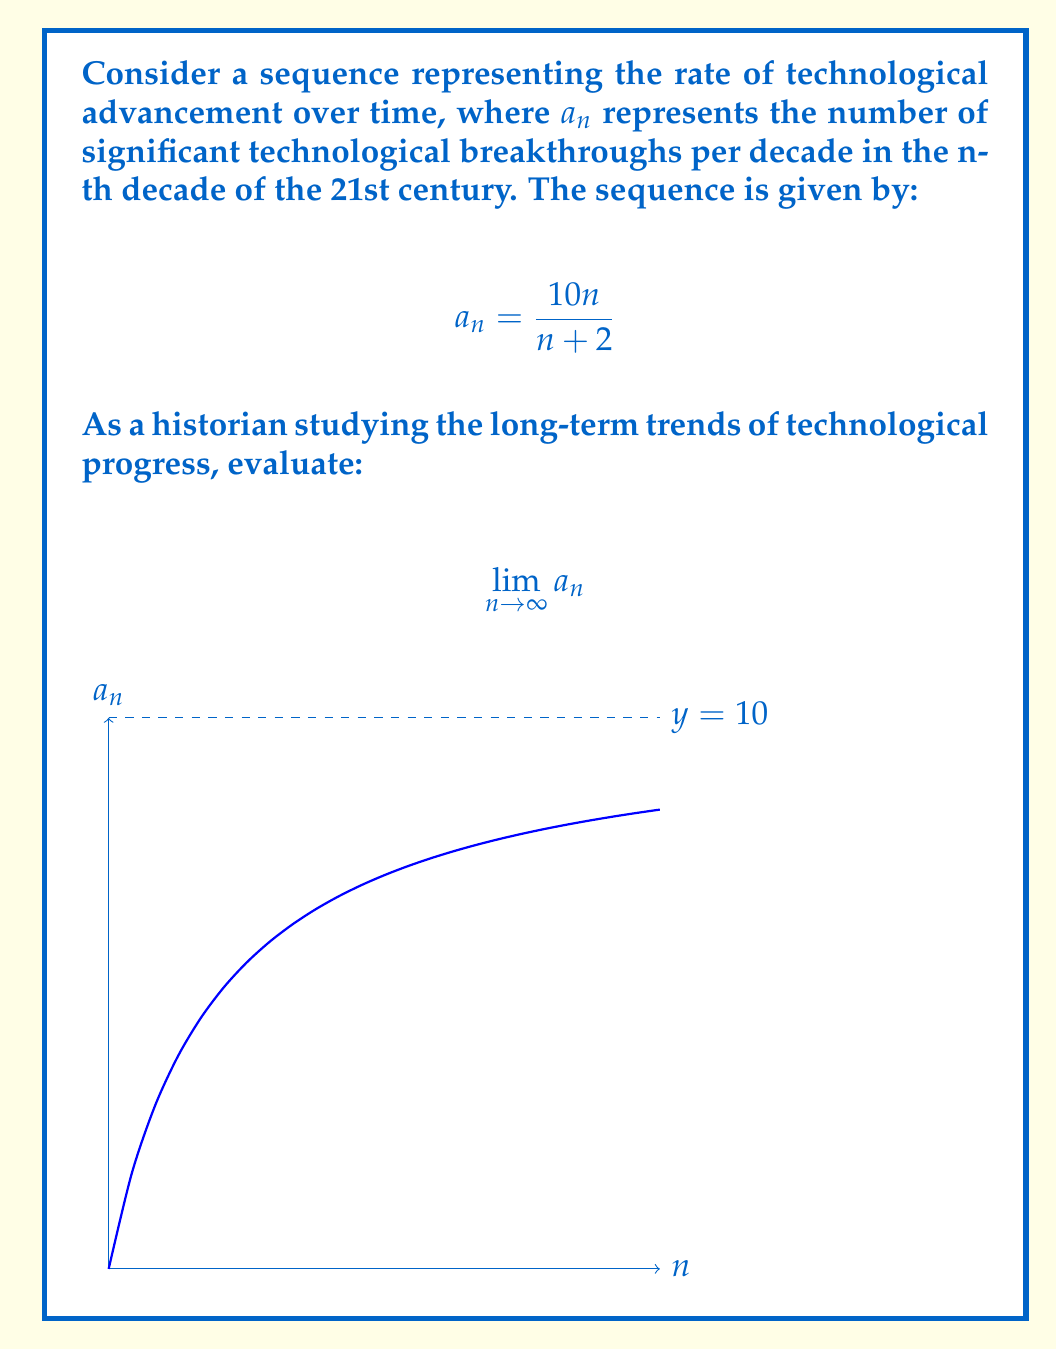Can you solve this math problem? To evaluate this limit, we'll follow these steps:

1) First, let's consider the behavior of the function as n approaches infinity:

   $$\lim_{n \to \infty} \frac{10n}{n+2}$$

2) Both the numerator and denominator approach infinity as n grows large. This is an indeterminate form of type $\frac{\infty}{\infty}$.

3) To resolve this, we can divide both the numerator and denominator by the highest power of n, which is n:

   $$\lim_{n \to \infty} \frac{10n}{n+2} = \lim_{n \to \infty} \frac{10n/n}{(n+2)/n} = \lim_{n \to \infty} \frac{10}{1+2/n}$$

4) As n approaches infinity, $2/n$ approaches 0:

   $$\lim_{n \to \infty} \frac{10}{1+2/n} = \frac{10}{1+0} = 10$$

5) Interpreting this result historically: As time progresses indefinitely, the model suggests that the rate of technological breakthroughs approaches 10 per decade, indicating a potential upper limit to the pace of innovation in this framework.
Answer: $10$ 